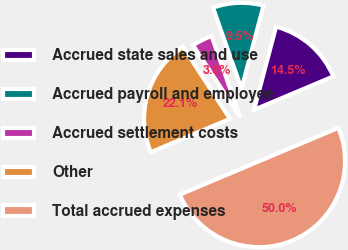Convert chart to OTSL. <chart><loc_0><loc_0><loc_500><loc_500><pie_chart><fcel>Accrued state sales and use<fcel>Accrued payroll and employee<fcel>Accrued settlement costs<fcel>Other<fcel>Total accrued expenses<nl><fcel>14.54%<fcel>9.49%<fcel>3.84%<fcel>22.14%<fcel>50.0%<nl></chart> 